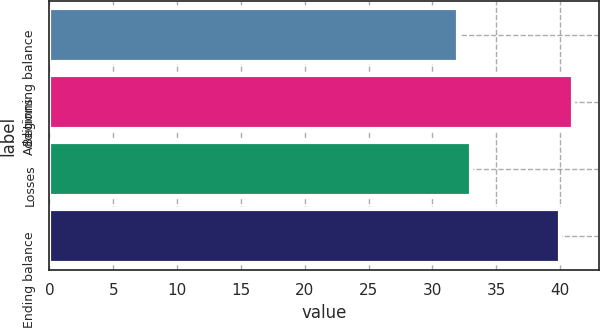Convert chart. <chart><loc_0><loc_0><loc_500><loc_500><bar_chart><fcel>Beginning balance<fcel>Additions<fcel>Losses<fcel>Ending balance<nl><fcel>32<fcel>41<fcel>33<fcel>40<nl></chart> 